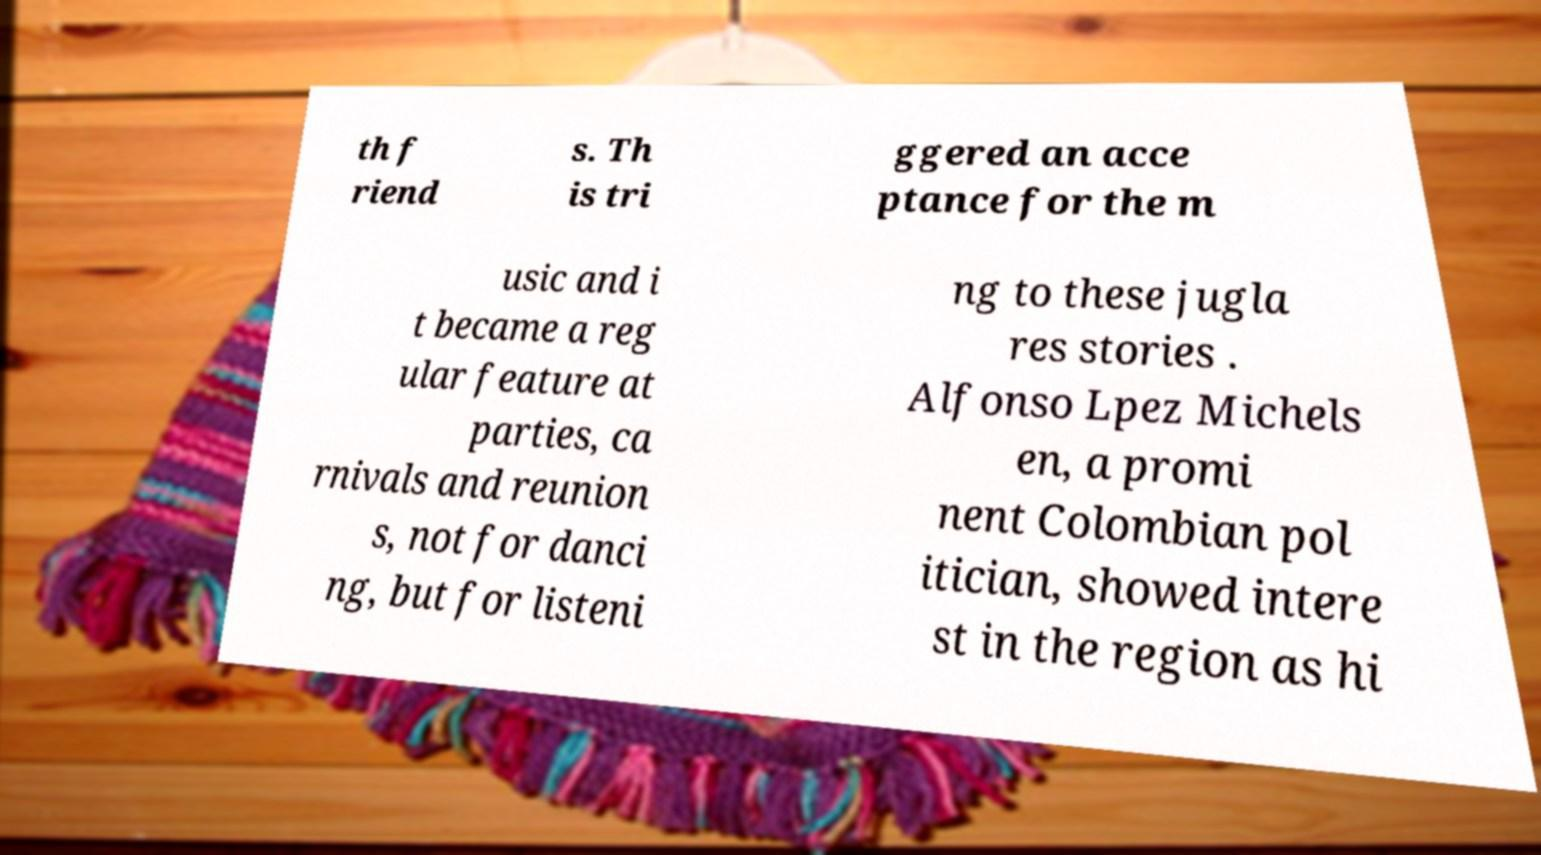Could you extract and type out the text from this image? th f riend s. Th is tri ggered an acce ptance for the m usic and i t became a reg ular feature at parties, ca rnivals and reunion s, not for danci ng, but for listeni ng to these jugla res stories . Alfonso Lpez Michels en, a promi nent Colombian pol itician, showed intere st in the region as hi 